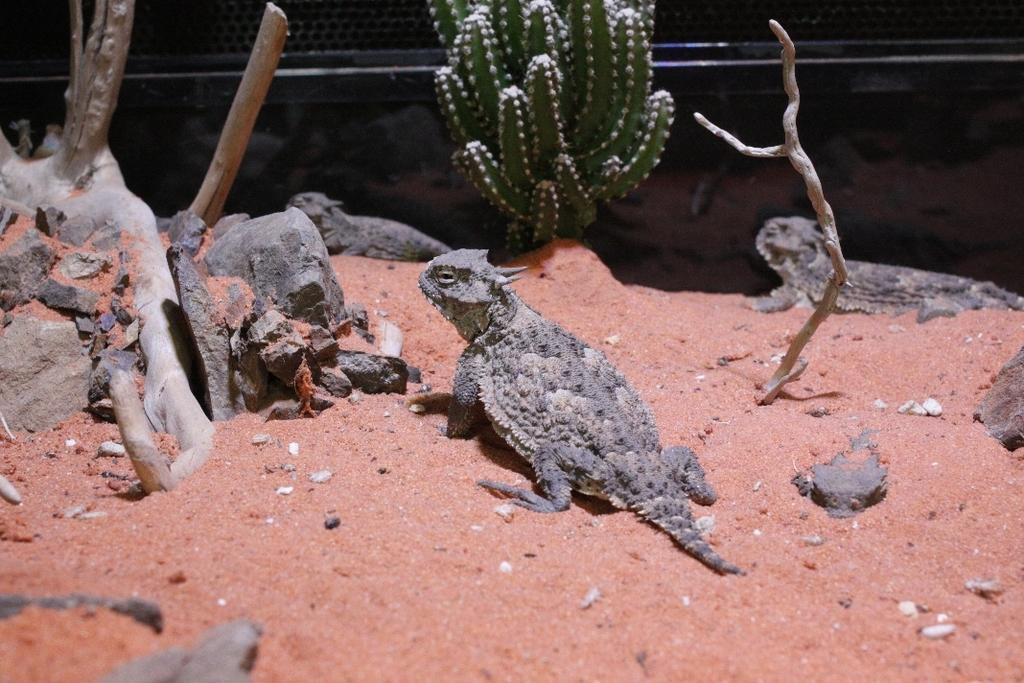Could you give a brief overview of what you see in this image? In this image we can see some reptiles on the sand. We can also see branches of a tree, some stones and a cactus. On the backside we can see a wall. 